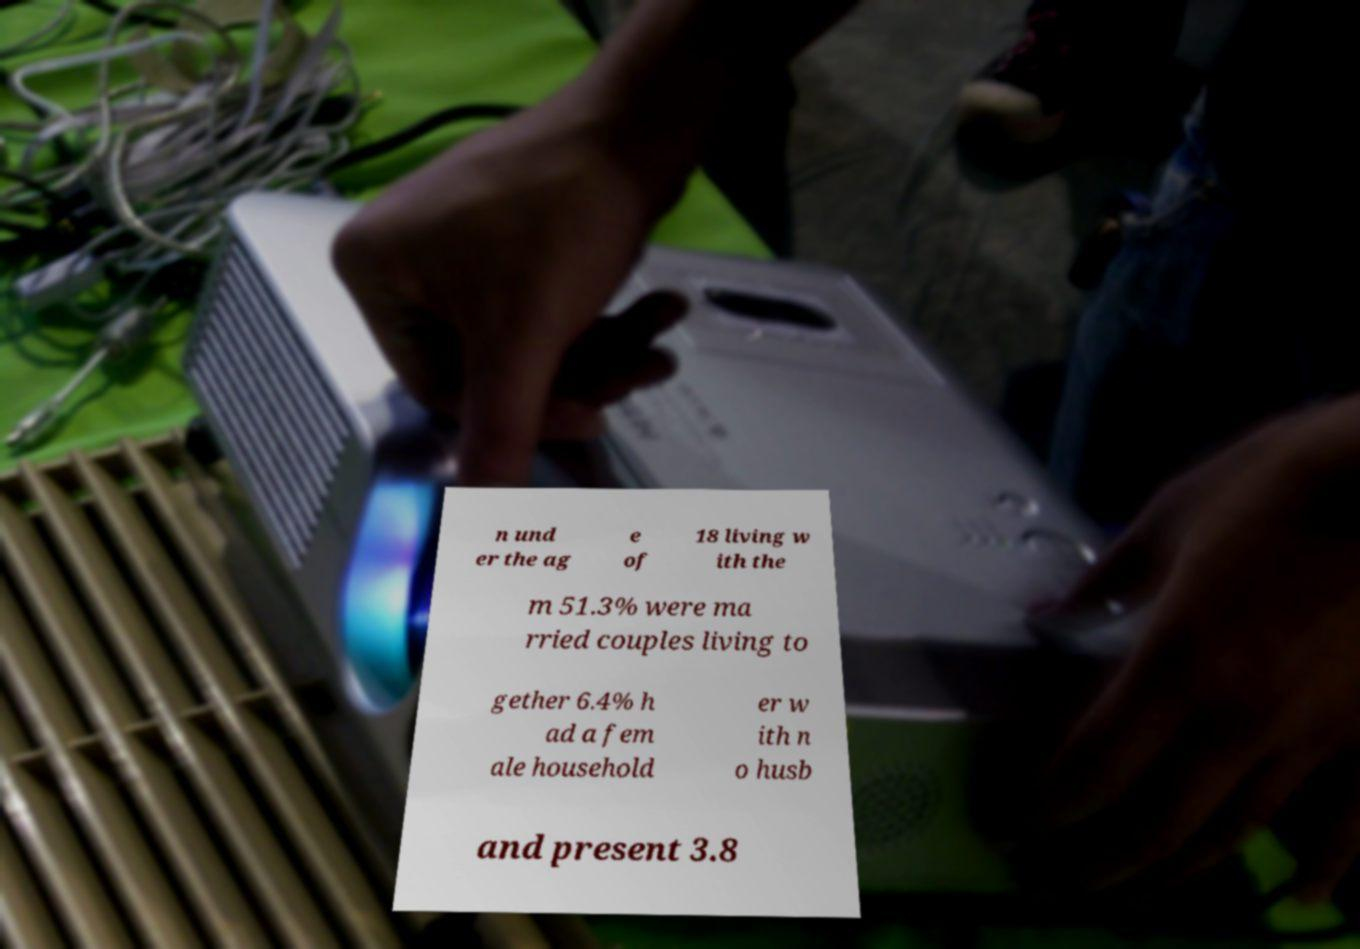I need the written content from this picture converted into text. Can you do that? n und er the ag e of 18 living w ith the m 51.3% were ma rried couples living to gether 6.4% h ad a fem ale household er w ith n o husb and present 3.8 